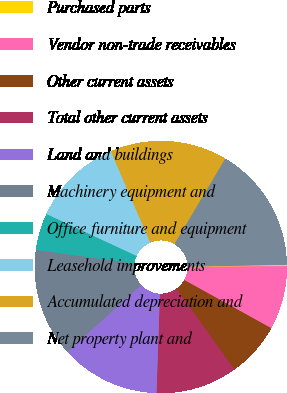<chart> <loc_0><loc_0><loc_500><loc_500><pie_chart><fcel>Purchased parts<fcel>Vendor non-trade receivables<fcel>Other current assets<fcel>Total other current assets<fcel>Land and buildings<fcel>Machinery equipment and<fcel>Office furniture and equipment<fcel>Leasehold improvements<fcel>Accumulated depreciation and<fcel>Net property plant and<nl><fcel>0.17%<fcel>8.17%<fcel>7.03%<fcel>10.46%<fcel>12.74%<fcel>13.89%<fcel>4.74%<fcel>11.6%<fcel>15.03%<fcel>16.17%<nl></chart> 